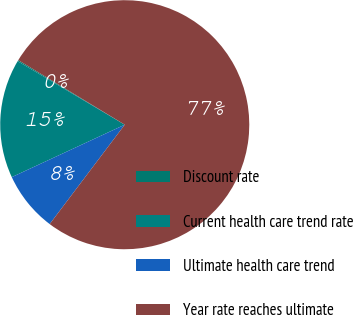<chart> <loc_0><loc_0><loc_500><loc_500><pie_chart><fcel>Discount rate<fcel>Current health care trend rate<fcel>Ultimate health care trend<fcel>Year rate reaches ultimate<nl><fcel>0.15%<fcel>15.44%<fcel>7.79%<fcel>76.62%<nl></chart> 